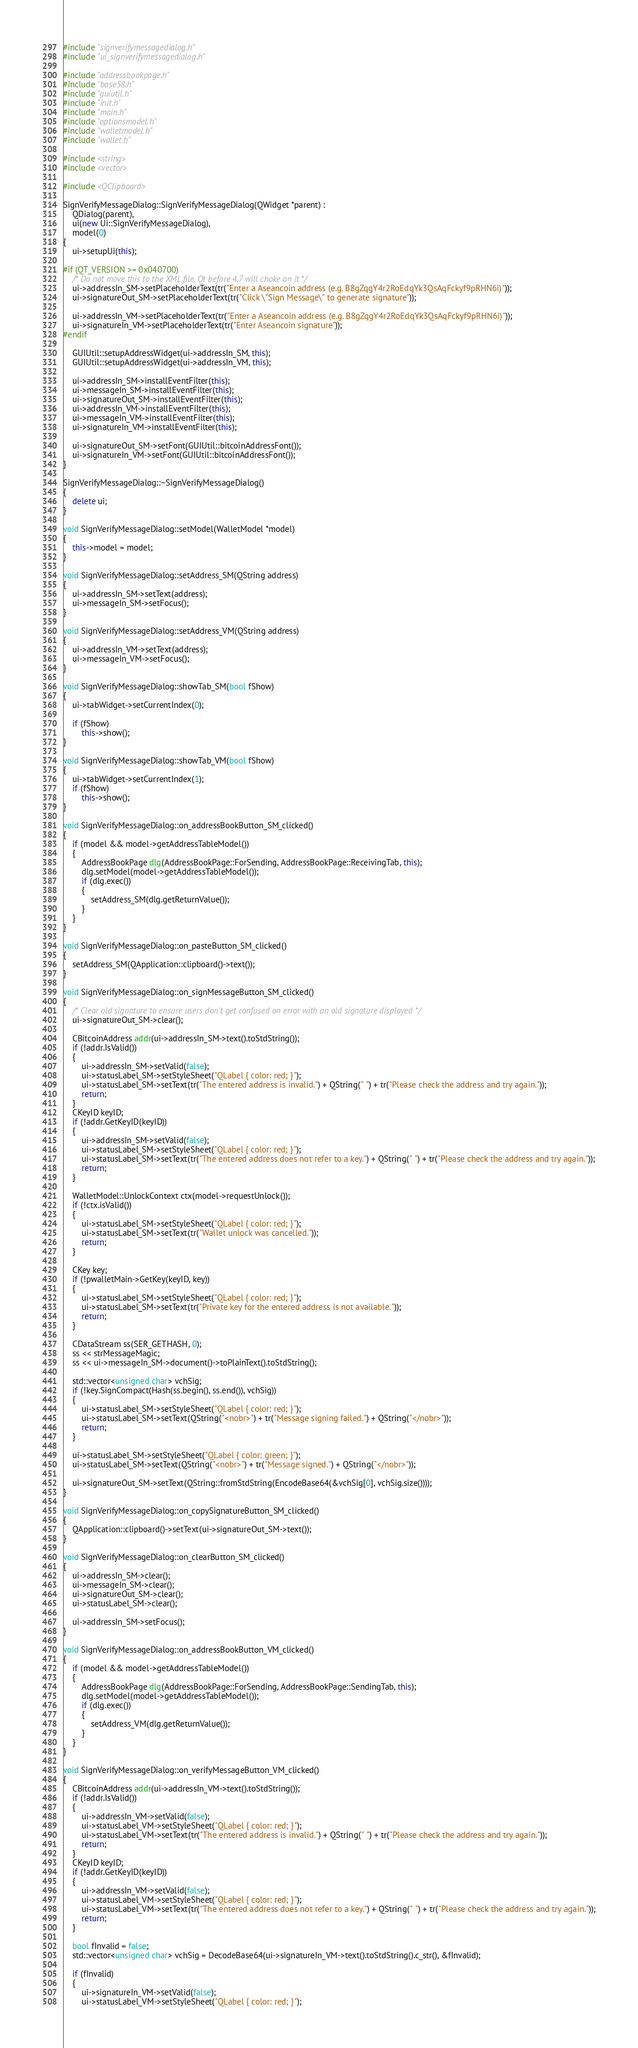<code> <loc_0><loc_0><loc_500><loc_500><_C++_>#include "signverifymessagedialog.h"
#include "ui_signverifymessagedialog.h"

#include "addressbookpage.h"
#include "base58.h"
#include "guiutil.h"
#include "init.h"
#include "main.h"
#include "optionsmodel.h"
#include "walletmodel.h"
#include "wallet.h"

#include <string>
#include <vector>

#include <QClipboard>

SignVerifyMessageDialog::SignVerifyMessageDialog(QWidget *parent) :
    QDialog(parent),
    ui(new Ui::SignVerifyMessageDialog),
    model(0)
{
    ui->setupUi(this);

#if (QT_VERSION >= 0x040700)
    /* Do not move this to the XML file, Qt before 4.7 will choke on it */
    ui->addressIn_SM->setPlaceholderText(tr("Enter a Aseancoin address (e.g. B8gZqgY4r2RoEdqYk3QsAqFckyf9pRHN6i)"));
    ui->signatureOut_SM->setPlaceholderText(tr("Click \"Sign Message\" to generate signature"));

    ui->addressIn_VM->setPlaceholderText(tr("Enter a Aseancoin address (e.g. B8gZqgY4r2RoEdqYk3QsAqFckyf9pRHN6i)"));
    ui->signatureIn_VM->setPlaceholderText(tr("Enter Aseancoin signature"));
#endif

    GUIUtil::setupAddressWidget(ui->addressIn_SM, this);
    GUIUtil::setupAddressWidget(ui->addressIn_VM, this);

    ui->addressIn_SM->installEventFilter(this);
    ui->messageIn_SM->installEventFilter(this);
    ui->signatureOut_SM->installEventFilter(this);
    ui->addressIn_VM->installEventFilter(this);
    ui->messageIn_VM->installEventFilter(this);
    ui->signatureIn_VM->installEventFilter(this);

    ui->signatureOut_SM->setFont(GUIUtil::bitcoinAddressFont());
    ui->signatureIn_VM->setFont(GUIUtil::bitcoinAddressFont());
}

SignVerifyMessageDialog::~SignVerifyMessageDialog()
{
    delete ui;
}

void SignVerifyMessageDialog::setModel(WalletModel *model)
{
    this->model = model;
}

void SignVerifyMessageDialog::setAddress_SM(QString address)
{
    ui->addressIn_SM->setText(address);
    ui->messageIn_SM->setFocus();
}

void SignVerifyMessageDialog::setAddress_VM(QString address)
{
    ui->addressIn_VM->setText(address);
    ui->messageIn_VM->setFocus();
}

void SignVerifyMessageDialog::showTab_SM(bool fShow)
{
    ui->tabWidget->setCurrentIndex(0);

    if (fShow)
        this->show();
}

void SignVerifyMessageDialog::showTab_VM(bool fShow)
{
    ui->tabWidget->setCurrentIndex(1);
    if (fShow)
        this->show();
}

void SignVerifyMessageDialog::on_addressBookButton_SM_clicked()
{
    if (model && model->getAddressTableModel())
    {
        AddressBookPage dlg(AddressBookPage::ForSending, AddressBookPage::ReceivingTab, this);
        dlg.setModel(model->getAddressTableModel());
        if (dlg.exec())
        {
            setAddress_SM(dlg.getReturnValue());
        }
    }
}

void SignVerifyMessageDialog::on_pasteButton_SM_clicked()
{
    setAddress_SM(QApplication::clipboard()->text());
}

void SignVerifyMessageDialog::on_signMessageButton_SM_clicked()
{
    /* Clear old signature to ensure users don't get confused on error with an old signature displayed */
    ui->signatureOut_SM->clear();

    CBitcoinAddress addr(ui->addressIn_SM->text().toStdString());
    if (!addr.IsValid())
    {
        ui->addressIn_SM->setValid(false);
        ui->statusLabel_SM->setStyleSheet("QLabel { color: red; }");
        ui->statusLabel_SM->setText(tr("The entered address is invalid.") + QString(" ") + tr("Please check the address and try again."));
        return;
    }
    CKeyID keyID;
    if (!addr.GetKeyID(keyID))
    {
        ui->addressIn_SM->setValid(false);
        ui->statusLabel_SM->setStyleSheet("QLabel { color: red; }");
        ui->statusLabel_SM->setText(tr("The entered address does not refer to a key.") + QString(" ") + tr("Please check the address and try again."));
        return;
    }

    WalletModel::UnlockContext ctx(model->requestUnlock());
    if (!ctx.isValid())
    {
        ui->statusLabel_SM->setStyleSheet("QLabel { color: red; }");
        ui->statusLabel_SM->setText(tr("Wallet unlock was cancelled."));
        return;
    }

    CKey key;
    if (!pwalletMain->GetKey(keyID, key))
    {
        ui->statusLabel_SM->setStyleSheet("QLabel { color: red; }");
        ui->statusLabel_SM->setText(tr("Private key for the entered address is not available."));
        return;
    }

    CDataStream ss(SER_GETHASH, 0);
    ss << strMessageMagic;
    ss << ui->messageIn_SM->document()->toPlainText().toStdString();

    std::vector<unsigned char> vchSig;
    if (!key.SignCompact(Hash(ss.begin(), ss.end()), vchSig))
    {
        ui->statusLabel_SM->setStyleSheet("QLabel { color: red; }");
        ui->statusLabel_SM->setText(QString("<nobr>") + tr("Message signing failed.") + QString("</nobr>"));
        return;
    }

    ui->statusLabel_SM->setStyleSheet("QLabel { color: green; }");
    ui->statusLabel_SM->setText(QString("<nobr>") + tr("Message signed.") + QString("</nobr>"));

    ui->signatureOut_SM->setText(QString::fromStdString(EncodeBase64(&vchSig[0], vchSig.size())));
}

void SignVerifyMessageDialog::on_copySignatureButton_SM_clicked()
{
    QApplication::clipboard()->setText(ui->signatureOut_SM->text());
}

void SignVerifyMessageDialog::on_clearButton_SM_clicked()
{
    ui->addressIn_SM->clear();
    ui->messageIn_SM->clear();
    ui->signatureOut_SM->clear();
    ui->statusLabel_SM->clear();

    ui->addressIn_SM->setFocus();
}

void SignVerifyMessageDialog::on_addressBookButton_VM_clicked()
{
    if (model && model->getAddressTableModel())
    {
        AddressBookPage dlg(AddressBookPage::ForSending, AddressBookPage::SendingTab, this);
        dlg.setModel(model->getAddressTableModel());
        if (dlg.exec())
        {
            setAddress_VM(dlg.getReturnValue());
        }
    }
}

void SignVerifyMessageDialog::on_verifyMessageButton_VM_clicked()
{
    CBitcoinAddress addr(ui->addressIn_VM->text().toStdString());
    if (!addr.IsValid())
    {
        ui->addressIn_VM->setValid(false);
        ui->statusLabel_VM->setStyleSheet("QLabel { color: red; }");
        ui->statusLabel_VM->setText(tr("The entered address is invalid.") + QString(" ") + tr("Please check the address and try again."));
        return;
    }
    CKeyID keyID;
    if (!addr.GetKeyID(keyID))
    {
        ui->addressIn_VM->setValid(false);
        ui->statusLabel_VM->setStyleSheet("QLabel { color: red; }");
        ui->statusLabel_VM->setText(tr("The entered address does not refer to a key.") + QString(" ") + tr("Please check the address and try again."));
        return;
    }

    bool fInvalid = false;
    std::vector<unsigned char> vchSig = DecodeBase64(ui->signatureIn_VM->text().toStdString().c_str(), &fInvalid);

    if (fInvalid)
    {
        ui->signatureIn_VM->setValid(false);
        ui->statusLabel_VM->setStyleSheet("QLabel { color: red; }");</code> 